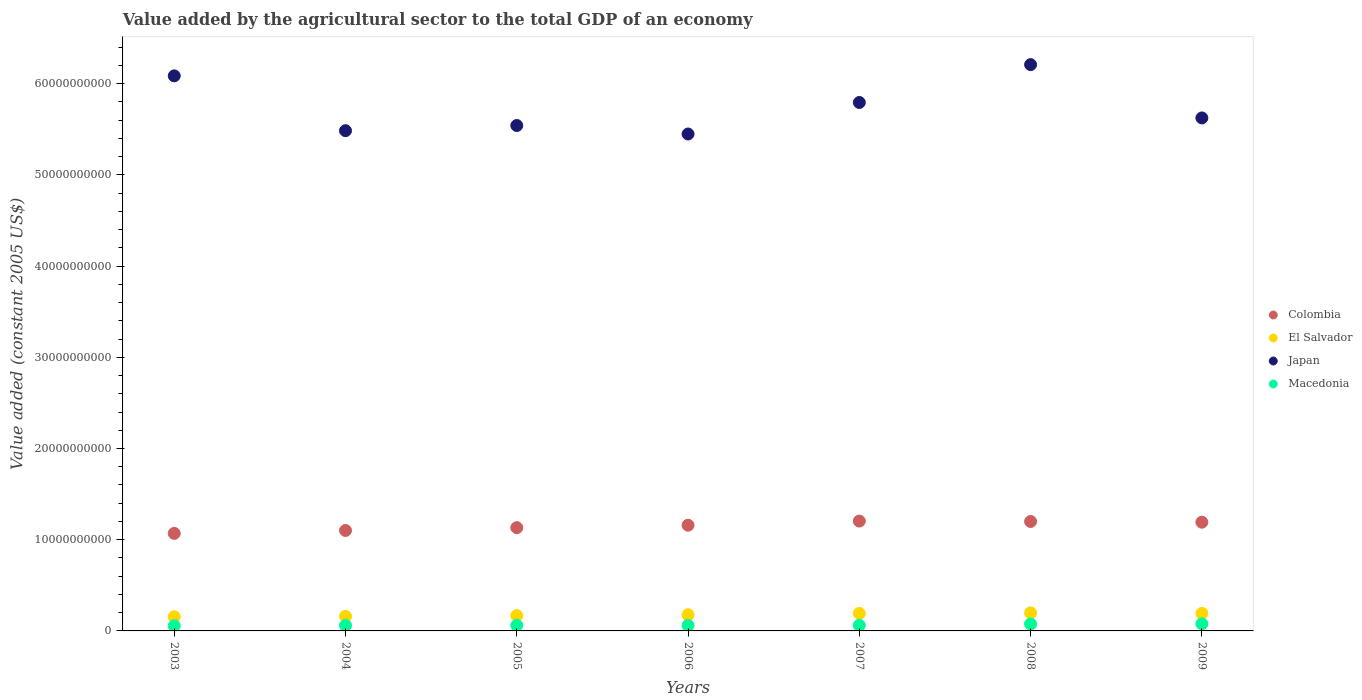Is the number of dotlines equal to the number of legend labels?
Your response must be concise. Yes. What is the value added by the agricultural sector in Colombia in 2009?
Keep it short and to the point. 1.19e+1. Across all years, what is the maximum value added by the agricultural sector in Japan?
Offer a terse response. 6.21e+1. Across all years, what is the minimum value added by the agricultural sector in El Salvador?
Your answer should be very brief. 1.55e+09. In which year was the value added by the agricultural sector in Japan minimum?
Your answer should be very brief. 2006. What is the total value added by the agricultural sector in Macedonia in the graph?
Give a very brief answer. 4.54e+09. What is the difference between the value added by the agricultural sector in El Salvador in 2007 and that in 2008?
Provide a succinct answer. -5.84e+07. What is the difference between the value added by the agricultural sector in El Salvador in 2005 and the value added by the agricultural sector in Japan in 2008?
Keep it short and to the point. -6.04e+1. What is the average value added by the agricultural sector in Japan per year?
Your response must be concise. 5.74e+1. In the year 2005, what is the difference between the value added by the agricultural sector in El Salvador and value added by the agricultural sector in Colombia?
Your answer should be very brief. -9.65e+09. What is the ratio of the value added by the agricultural sector in Colombia in 2004 to that in 2005?
Your answer should be compact. 0.97. Is the difference between the value added by the agricultural sector in El Salvador in 2004 and 2005 greater than the difference between the value added by the agricultural sector in Colombia in 2004 and 2005?
Give a very brief answer. Yes. What is the difference between the highest and the second highest value added by the agricultural sector in Colombia?
Keep it short and to the point. 4.52e+07. What is the difference between the highest and the lowest value added by the agricultural sector in El Salvador?
Offer a very short reply. 4.28e+08. In how many years, is the value added by the agricultural sector in Macedonia greater than the average value added by the agricultural sector in Macedonia taken over all years?
Give a very brief answer. 2. Is the sum of the value added by the agricultural sector in Colombia in 2003 and 2006 greater than the maximum value added by the agricultural sector in Japan across all years?
Offer a very short reply. No. Is it the case that in every year, the sum of the value added by the agricultural sector in Japan and value added by the agricultural sector in El Salvador  is greater than the sum of value added by the agricultural sector in Macedonia and value added by the agricultural sector in Colombia?
Offer a very short reply. Yes. Does the value added by the agricultural sector in Macedonia monotonically increase over the years?
Make the answer very short. No. How many years are there in the graph?
Your answer should be compact. 7. What is the difference between two consecutive major ticks on the Y-axis?
Your answer should be very brief. 1.00e+1. Does the graph contain grids?
Keep it short and to the point. No. How many legend labels are there?
Offer a terse response. 4. What is the title of the graph?
Your answer should be very brief. Value added by the agricultural sector to the total GDP of an economy. What is the label or title of the X-axis?
Make the answer very short. Years. What is the label or title of the Y-axis?
Offer a terse response. Value added (constant 2005 US$). What is the Value added (constant 2005 US$) of Colombia in 2003?
Your response must be concise. 1.07e+1. What is the Value added (constant 2005 US$) in El Salvador in 2003?
Ensure brevity in your answer.  1.55e+09. What is the Value added (constant 2005 US$) of Japan in 2003?
Your response must be concise. 6.09e+1. What is the Value added (constant 2005 US$) in Macedonia in 2003?
Your answer should be very brief. 5.65e+08. What is the Value added (constant 2005 US$) of Colombia in 2004?
Ensure brevity in your answer.  1.10e+1. What is the Value added (constant 2005 US$) of El Salvador in 2004?
Offer a very short reply. 1.60e+09. What is the Value added (constant 2005 US$) of Japan in 2004?
Give a very brief answer. 5.48e+1. What is the Value added (constant 2005 US$) in Macedonia in 2004?
Offer a very short reply. 6.04e+08. What is the Value added (constant 2005 US$) of Colombia in 2005?
Provide a succinct answer. 1.13e+1. What is the Value added (constant 2005 US$) of El Salvador in 2005?
Make the answer very short. 1.68e+09. What is the Value added (constant 2005 US$) of Japan in 2005?
Make the answer very short. 5.54e+1. What is the Value added (constant 2005 US$) in Macedonia in 2005?
Your response must be concise. 6.09e+08. What is the Value added (constant 2005 US$) in Colombia in 2006?
Your response must be concise. 1.16e+1. What is the Value added (constant 2005 US$) of El Salvador in 2006?
Provide a succinct answer. 1.77e+09. What is the Value added (constant 2005 US$) in Japan in 2006?
Your response must be concise. 5.45e+1. What is the Value added (constant 2005 US$) of Macedonia in 2006?
Keep it short and to the point. 6.06e+08. What is the Value added (constant 2005 US$) of Colombia in 2007?
Offer a terse response. 1.20e+1. What is the Value added (constant 2005 US$) of El Salvador in 2007?
Your answer should be compact. 1.92e+09. What is the Value added (constant 2005 US$) in Japan in 2007?
Your response must be concise. 5.79e+1. What is the Value added (constant 2005 US$) of Macedonia in 2007?
Make the answer very short. 6.19e+08. What is the Value added (constant 2005 US$) in Colombia in 2008?
Ensure brevity in your answer.  1.20e+1. What is the Value added (constant 2005 US$) of El Salvador in 2008?
Provide a short and direct response. 1.98e+09. What is the Value added (constant 2005 US$) of Japan in 2008?
Your response must be concise. 6.21e+1. What is the Value added (constant 2005 US$) of Macedonia in 2008?
Offer a terse response. 7.55e+08. What is the Value added (constant 2005 US$) in Colombia in 2009?
Offer a very short reply. 1.19e+1. What is the Value added (constant 2005 US$) of El Salvador in 2009?
Give a very brief answer. 1.92e+09. What is the Value added (constant 2005 US$) in Japan in 2009?
Your response must be concise. 5.62e+1. What is the Value added (constant 2005 US$) in Macedonia in 2009?
Keep it short and to the point. 7.81e+08. Across all years, what is the maximum Value added (constant 2005 US$) in Colombia?
Keep it short and to the point. 1.20e+1. Across all years, what is the maximum Value added (constant 2005 US$) of El Salvador?
Ensure brevity in your answer.  1.98e+09. Across all years, what is the maximum Value added (constant 2005 US$) of Japan?
Give a very brief answer. 6.21e+1. Across all years, what is the maximum Value added (constant 2005 US$) of Macedonia?
Make the answer very short. 7.81e+08. Across all years, what is the minimum Value added (constant 2005 US$) of Colombia?
Provide a short and direct response. 1.07e+1. Across all years, what is the minimum Value added (constant 2005 US$) of El Salvador?
Give a very brief answer. 1.55e+09. Across all years, what is the minimum Value added (constant 2005 US$) in Japan?
Provide a short and direct response. 5.45e+1. Across all years, what is the minimum Value added (constant 2005 US$) in Macedonia?
Provide a succinct answer. 5.65e+08. What is the total Value added (constant 2005 US$) of Colombia in the graph?
Your response must be concise. 8.06e+1. What is the total Value added (constant 2005 US$) in El Salvador in the graph?
Your answer should be very brief. 1.24e+1. What is the total Value added (constant 2005 US$) in Japan in the graph?
Provide a short and direct response. 4.02e+11. What is the total Value added (constant 2005 US$) of Macedonia in the graph?
Offer a very short reply. 4.54e+09. What is the difference between the Value added (constant 2005 US$) in Colombia in 2003 and that in 2004?
Offer a terse response. -3.18e+08. What is the difference between the Value added (constant 2005 US$) in El Salvador in 2003 and that in 2004?
Offer a very short reply. -4.36e+07. What is the difference between the Value added (constant 2005 US$) in Japan in 2003 and that in 2004?
Your answer should be compact. 6.01e+09. What is the difference between the Value added (constant 2005 US$) in Macedonia in 2003 and that in 2004?
Offer a very short reply. -3.82e+07. What is the difference between the Value added (constant 2005 US$) of Colombia in 2003 and that in 2005?
Your response must be concise. -6.28e+08. What is the difference between the Value added (constant 2005 US$) of El Salvador in 2003 and that in 2005?
Ensure brevity in your answer.  -1.25e+08. What is the difference between the Value added (constant 2005 US$) in Japan in 2003 and that in 2005?
Ensure brevity in your answer.  5.44e+09. What is the difference between the Value added (constant 2005 US$) in Macedonia in 2003 and that in 2005?
Offer a very short reply. -4.40e+07. What is the difference between the Value added (constant 2005 US$) of Colombia in 2003 and that in 2006?
Your answer should be very brief. -8.97e+08. What is the difference between the Value added (constant 2005 US$) in El Salvador in 2003 and that in 2006?
Your response must be concise. -2.20e+08. What is the difference between the Value added (constant 2005 US$) in Japan in 2003 and that in 2006?
Offer a very short reply. 6.38e+09. What is the difference between the Value added (constant 2005 US$) of Macedonia in 2003 and that in 2006?
Your response must be concise. -4.07e+07. What is the difference between the Value added (constant 2005 US$) in Colombia in 2003 and that in 2007?
Offer a terse response. -1.35e+09. What is the difference between the Value added (constant 2005 US$) in El Salvador in 2003 and that in 2007?
Provide a short and direct response. -3.70e+08. What is the difference between the Value added (constant 2005 US$) in Japan in 2003 and that in 2007?
Offer a terse response. 2.92e+09. What is the difference between the Value added (constant 2005 US$) of Macedonia in 2003 and that in 2007?
Your answer should be compact. -5.37e+07. What is the difference between the Value added (constant 2005 US$) of Colombia in 2003 and that in 2008?
Provide a short and direct response. -1.30e+09. What is the difference between the Value added (constant 2005 US$) of El Salvador in 2003 and that in 2008?
Your answer should be compact. -4.28e+08. What is the difference between the Value added (constant 2005 US$) of Japan in 2003 and that in 2008?
Offer a very short reply. -1.23e+09. What is the difference between the Value added (constant 2005 US$) of Macedonia in 2003 and that in 2008?
Provide a succinct answer. -1.90e+08. What is the difference between the Value added (constant 2005 US$) of Colombia in 2003 and that in 2009?
Give a very brief answer. -1.23e+09. What is the difference between the Value added (constant 2005 US$) in El Salvador in 2003 and that in 2009?
Keep it short and to the point. -3.71e+08. What is the difference between the Value added (constant 2005 US$) in Japan in 2003 and that in 2009?
Your response must be concise. 4.61e+09. What is the difference between the Value added (constant 2005 US$) in Macedonia in 2003 and that in 2009?
Keep it short and to the point. -2.16e+08. What is the difference between the Value added (constant 2005 US$) of Colombia in 2004 and that in 2005?
Your answer should be very brief. -3.10e+08. What is the difference between the Value added (constant 2005 US$) of El Salvador in 2004 and that in 2005?
Provide a short and direct response. -8.10e+07. What is the difference between the Value added (constant 2005 US$) in Japan in 2004 and that in 2005?
Make the answer very short. -5.68e+08. What is the difference between the Value added (constant 2005 US$) in Macedonia in 2004 and that in 2005?
Provide a succinct answer. -5.80e+06. What is the difference between the Value added (constant 2005 US$) of Colombia in 2004 and that in 2006?
Offer a very short reply. -5.78e+08. What is the difference between the Value added (constant 2005 US$) in El Salvador in 2004 and that in 2006?
Give a very brief answer. -1.76e+08. What is the difference between the Value added (constant 2005 US$) in Japan in 2004 and that in 2006?
Make the answer very short. 3.65e+08. What is the difference between the Value added (constant 2005 US$) of Macedonia in 2004 and that in 2006?
Provide a short and direct response. -2.50e+06. What is the difference between the Value added (constant 2005 US$) in Colombia in 2004 and that in 2007?
Give a very brief answer. -1.03e+09. What is the difference between the Value added (constant 2005 US$) of El Salvador in 2004 and that in 2007?
Ensure brevity in your answer.  -3.26e+08. What is the difference between the Value added (constant 2005 US$) of Japan in 2004 and that in 2007?
Offer a very short reply. -3.09e+09. What is the difference between the Value added (constant 2005 US$) in Macedonia in 2004 and that in 2007?
Your response must be concise. -1.56e+07. What is the difference between the Value added (constant 2005 US$) in Colombia in 2004 and that in 2008?
Your response must be concise. -9.86e+08. What is the difference between the Value added (constant 2005 US$) of El Salvador in 2004 and that in 2008?
Offer a very short reply. -3.84e+08. What is the difference between the Value added (constant 2005 US$) of Japan in 2004 and that in 2008?
Keep it short and to the point. -7.24e+09. What is the difference between the Value added (constant 2005 US$) in Macedonia in 2004 and that in 2008?
Make the answer very short. -1.52e+08. What is the difference between the Value added (constant 2005 US$) of Colombia in 2004 and that in 2009?
Give a very brief answer. -9.08e+08. What is the difference between the Value added (constant 2005 US$) in El Salvador in 2004 and that in 2009?
Ensure brevity in your answer.  -3.27e+08. What is the difference between the Value added (constant 2005 US$) in Japan in 2004 and that in 2009?
Offer a very short reply. -1.40e+09. What is the difference between the Value added (constant 2005 US$) of Macedonia in 2004 and that in 2009?
Keep it short and to the point. -1.77e+08. What is the difference between the Value added (constant 2005 US$) of Colombia in 2005 and that in 2006?
Keep it short and to the point. -2.68e+08. What is the difference between the Value added (constant 2005 US$) of El Salvador in 2005 and that in 2006?
Make the answer very short. -9.51e+07. What is the difference between the Value added (constant 2005 US$) in Japan in 2005 and that in 2006?
Your response must be concise. 9.33e+08. What is the difference between the Value added (constant 2005 US$) of Macedonia in 2005 and that in 2006?
Your response must be concise. 3.31e+06. What is the difference between the Value added (constant 2005 US$) in Colombia in 2005 and that in 2007?
Your answer should be compact. -7.22e+08. What is the difference between the Value added (constant 2005 US$) in El Salvador in 2005 and that in 2007?
Make the answer very short. -2.45e+08. What is the difference between the Value added (constant 2005 US$) of Japan in 2005 and that in 2007?
Keep it short and to the point. -2.52e+09. What is the difference between the Value added (constant 2005 US$) of Macedonia in 2005 and that in 2007?
Your response must be concise. -9.75e+06. What is the difference between the Value added (constant 2005 US$) in Colombia in 2005 and that in 2008?
Give a very brief answer. -6.76e+08. What is the difference between the Value added (constant 2005 US$) in El Salvador in 2005 and that in 2008?
Your response must be concise. -3.03e+08. What is the difference between the Value added (constant 2005 US$) of Japan in 2005 and that in 2008?
Offer a very short reply. -6.67e+09. What is the difference between the Value added (constant 2005 US$) of Macedonia in 2005 and that in 2008?
Offer a terse response. -1.46e+08. What is the difference between the Value added (constant 2005 US$) in Colombia in 2005 and that in 2009?
Your answer should be compact. -5.98e+08. What is the difference between the Value added (constant 2005 US$) in El Salvador in 2005 and that in 2009?
Ensure brevity in your answer.  -2.46e+08. What is the difference between the Value added (constant 2005 US$) in Japan in 2005 and that in 2009?
Your answer should be very brief. -8.29e+08. What is the difference between the Value added (constant 2005 US$) of Macedonia in 2005 and that in 2009?
Ensure brevity in your answer.  -1.72e+08. What is the difference between the Value added (constant 2005 US$) of Colombia in 2006 and that in 2007?
Provide a succinct answer. -4.53e+08. What is the difference between the Value added (constant 2005 US$) of El Salvador in 2006 and that in 2007?
Your answer should be compact. -1.50e+08. What is the difference between the Value added (constant 2005 US$) in Japan in 2006 and that in 2007?
Provide a succinct answer. -3.46e+09. What is the difference between the Value added (constant 2005 US$) of Macedonia in 2006 and that in 2007?
Offer a very short reply. -1.31e+07. What is the difference between the Value added (constant 2005 US$) in Colombia in 2006 and that in 2008?
Keep it short and to the point. -4.08e+08. What is the difference between the Value added (constant 2005 US$) in El Salvador in 2006 and that in 2008?
Offer a very short reply. -2.08e+08. What is the difference between the Value added (constant 2005 US$) of Japan in 2006 and that in 2008?
Your response must be concise. -7.61e+09. What is the difference between the Value added (constant 2005 US$) of Macedonia in 2006 and that in 2008?
Your response must be concise. -1.49e+08. What is the difference between the Value added (constant 2005 US$) of Colombia in 2006 and that in 2009?
Your answer should be compact. -3.30e+08. What is the difference between the Value added (constant 2005 US$) of El Salvador in 2006 and that in 2009?
Provide a succinct answer. -1.51e+08. What is the difference between the Value added (constant 2005 US$) in Japan in 2006 and that in 2009?
Provide a short and direct response. -1.76e+09. What is the difference between the Value added (constant 2005 US$) of Macedonia in 2006 and that in 2009?
Ensure brevity in your answer.  -1.75e+08. What is the difference between the Value added (constant 2005 US$) in Colombia in 2007 and that in 2008?
Provide a succinct answer. 4.52e+07. What is the difference between the Value added (constant 2005 US$) of El Salvador in 2007 and that in 2008?
Provide a succinct answer. -5.84e+07. What is the difference between the Value added (constant 2005 US$) of Japan in 2007 and that in 2008?
Your response must be concise. -4.15e+09. What is the difference between the Value added (constant 2005 US$) in Macedonia in 2007 and that in 2008?
Your answer should be compact. -1.36e+08. What is the difference between the Value added (constant 2005 US$) in Colombia in 2007 and that in 2009?
Offer a terse response. 1.24e+08. What is the difference between the Value added (constant 2005 US$) of El Salvador in 2007 and that in 2009?
Keep it short and to the point. -1.02e+06. What is the difference between the Value added (constant 2005 US$) of Japan in 2007 and that in 2009?
Provide a succinct answer. 1.69e+09. What is the difference between the Value added (constant 2005 US$) of Macedonia in 2007 and that in 2009?
Ensure brevity in your answer.  -1.62e+08. What is the difference between the Value added (constant 2005 US$) of Colombia in 2008 and that in 2009?
Make the answer very short. 7.84e+07. What is the difference between the Value added (constant 2005 US$) of El Salvador in 2008 and that in 2009?
Ensure brevity in your answer.  5.73e+07. What is the difference between the Value added (constant 2005 US$) of Japan in 2008 and that in 2009?
Offer a terse response. 5.84e+09. What is the difference between the Value added (constant 2005 US$) in Macedonia in 2008 and that in 2009?
Offer a terse response. -2.57e+07. What is the difference between the Value added (constant 2005 US$) in Colombia in 2003 and the Value added (constant 2005 US$) in El Salvador in 2004?
Keep it short and to the point. 9.10e+09. What is the difference between the Value added (constant 2005 US$) in Colombia in 2003 and the Value added (constant 2005 US$) in Japan in 2004?
Keep it short and to the point. -4.42e+1. What is the difference between the Value added (constant 2005 US$) in Colombia in 2003 and the Value added (constant 2005 US$) in Macedonia in 2004?
Your answer should be compact. 1.01e+1. What is the difference between the Value added (constant 2005 US$) of El Salvador in 2003 and the Value added (constant 2005 US$) of Japan in 2004?
Provide a succinct answer. -5.33e+1. What is the difference between the Value added (constant 2005 US$) of El Salvador in 2003 and the Value added (constant 2005 US$) of Macedonia in 2004?
Your answer should be compact. 9.49e+08. What is the difference between the Value added (constant 2005 US$) of Japan in 2003 and the Value added (constant 2005 US$) of Macedonia in 2004?
Give a very brief answer. 6.03e+1. What is the difference between the Value added (constant 2005 US$) of Colombia in 2003 and the Value added (constant 2005 US$) of El Salvador in 2005?
Give a very brief answer. 9.02e+09. What is the difference between the Value added (constant 2005 US$) of Colombia in 2003 and the Value added (constant 2005 US$) of Japan in 2005?
Your response must be concise. -4.47e+1. What is the difference between the Value added (constant 2005 US$) in Colombia in 2003 and the Value added (constant 2005 US$) in Macedonia in 2005?
Make the answer very short. 1.01e+1. What is the difference between the Value added (constant 2005 US$) of El Salvador in 2003 and the Value added (constant 2005 US$) of Japan in 2005?
Ensure brevity in your answer.  -5.39e+1. What is the difference between the Value added (constant 2005 US$) in El Salvador in 2003 and the Value added (constant 2005 US$) in Macedonia in 2005?
Offer a terse response. 9.43e+08. What is the difference between the Value added (constant 2005 US$) of Japan in 2003 and the Value added (constant 2005 US$) of Macedonia in 2005?
Make the answer very short. 6.02e+1. What is the difference between the Value added (constant 2005 US$) of Colombia in 2003 and the Value added (constant 2005 US$) of El Salvador in 2006?
Provide a succinct answer. 8.92e+09. What is the difference between the Value added (constant 2005 US$) in Colombia in 2003 and the Value added (constant 2005 US$) in Japan in 2006?
Give a very brief answer. -4.38e+1. What is the difference between the Value added (constant 2005 US$) in Colombia in 2003 and the Value added (constant 2005 US$) in Macedonia in 2006?
Your response must be concise. 1.01e+1. What is the difference between the Value added (constant 2005 US$) in El Salvador in 2003 and the Value added (constant 2005 US$) in Japan in 2006?
Make the answer very short. -5.29e+1. What is the difference between the Value added (constant 2005 US$) in El Salvador in 2003 and the Value added (constant 2005 US$) in Macedonia in 2006?
Offer a terse response. 9.46e+08. What is the difference between the Value added (constant 2005 US$) of Japan in 2003 and the Value added (constant 2005 US$) of Macedonia in 2006?
Your response must be concise. 6.03e+1. What is the difference between the Value added (constant 2005 US$) in Colombia in 2003 and the Value added (constant 2005 US$) in El Salvador in 2007?
Give a very brief answer. 8.77e+09. What is the difference between the Value added (constant 2005 US$) of Colombia in 2003 and the Value added (constant 2005 US$) of Japan in 2007?
Provide a succinct answer. -4.72e+1. What is the difference between the Value added (constant 2005 US$) in Colombia in 2003 and the Value added (constant 2005 US$) in Macedonia in 2007?
Your answer should be compact. 1.01e+1. What is the difference between the Value added (constant 2005 US$) in El Salvador in 2003 and the Value added (constant 2005 US$) in Japan in 2007?
Ensure brevity in your answer.  -5.64e+1. What is the difference between the Value added (constant 2005 US$) in El Salvador in 2003 and the Value added (constant 2005 US$) in Macedonia in 2007?
Make the answer very short. 9.33e+08. What is the difference between the Value added (constant 2005 US$) of Japan in 2003 and the Value added (constant 2005 US$) of Macedonia in 2007?
Give a very brief answer. 6.02e+1. What is the difference between the Value added (constant 2005 US$) in Colombia in 2003 and the Value added (constant 2005 US$) in El Salvador in 2008?
Offer a very short reply. 8.71e+09. What is the difference between the Value added (constant 2005 US$) in Colombia in 2003 and the Value added (constant 2005 US$) in Japan in 2008?
Keep it short and to the point. -5.14e+1. What is the difference between the Value added (constant 2005 US$) of Colombia in 2003 and the Value added (constant 2005 US$) of Macedonia in 2008?
Your answer should be compact. 9.94e+09. What is the difference between the Value added (constant 2005 US$) of El Salvador in 2003 and the Value added (constant 2005 US$) of Japan in 2008?
Your answer should be compact. -6.05e+1. What is the difference between the Value added (constant 2005 US$) in El Salvador in 2003 and the Value added (constant 2005 US$) in Macedonia in 2008?
Ensure brevity in your answer.  7.97e+08. What is the difference between the Value added (constant 2005 US$) in Japan in 2003 and the Value added (constant 2005 US$) in Macedonia in 2008?
Your answer should be very brief. 6.01e+1. What is the difference between the Value added (constant 2005 US$) in Colombia in 2003 and the Value added (constant 2005 US$) in El Salvador in 2009?
Give a very brief answer. 8.77e+09. What is the difference between the Value added (constant 2005 US$) in Colombia in 2003 and the Value added (constant 2005 US$) in Japan in 2009?
Ensure brevity in your answer.  -4.55e+1. What is the difference between the Value added (constant 2005 US$) in Colombia in 2003 and the Value added (constant 2005 US$) in Macedonia in 2009?
Ensure brevity in your answer.  9.91e+09. What is the difference between the Value added (constant 2005 US$) in El Salvador in 2003 and the Value added (constant 2005 US$) in Japan in 2009?
Provide a succinct answer. -5.47e+1. What is the difference between the Value added (constant 2005 US$) of El Salvador in 2003 and the Value added (constant 2005 US$) of Macedonia in 2009?
Keep it short and to the point. 7.72e+08. What is the difference between the Value added (constant 2005 US$) in Japan in 2003 and the Value added (constant 2005 US$) in Macedonia in 2009?
Give a very brief answer. 6.01e+1. What is the difference between the Value added (constant 2005 US$) in Colombia in 2004 and the Value added (constant 2005 US$) in El Salvador in 2005?
Your response must be concise. 9.34e+09. What is the difference between the Value added (constant 2005 US$) of Colombia in 2004 and the Value added (constant 2005 US$) of Japan in 2005?
Your response must be concise. -4.44e+1. What is the difference between the Value added (constant 2005 US$) in Colombia in 2004 and the Value added (constant 2005 US$) in Macedonia in 2005?
Provide a succinct answer. 1.04e+1. What is the difference between the Value added (constant 2005 US$) in El Salvador in 2004 and the Value added (constant 2005 US$) in Japan in 2005?
Provide a short and direct response. -5.38e+1. What is the difference between the Value added (constant 2005 US$) in El Salvador in 2004 and the Value added (constant 2005 US$) in Macedonia in 2005?
Your response must be concise. 9.87e+08. What is the difference between the Value added (constant 2005 US$) in Japan in 2004 and the Value added (constant 2005 US$) in Macedonia in 2005?
Give a very brief answer. 5.42e+1. What is the difference between the Value added (constant 2005 US$) in Colombia in 2004 and the Value added (constant 2005 US$) in El Salvador in 2006?
Ensure brevity in your answer.  9.24e+09. What is the difference between the Value added (constant 2005 US$) in Colombia in 2004 and the Value added (constant 2005 US$) in Japan in 2006?
Your answer should be very brief. -4.35e+1. What is the difference between the Value added (constant 2005 US$) in Colombia in 2004 and the Value added (constant 2005 US$) in Macedonia in 2006?
Keep it short and to the point. 1.04e+1. What is the difference between the Value added (constant 2005 US$) of El Salvador in 2004 and the Value added (constant 2005 US$) of Japan in 2006?
Your answer should be very brief. -5.29e+1. What is the difference between the Value added (constant 2005 US$) in El Salvador in 2004 and the Value added (constant 2005 US$) in Macedonia in 2006?
Make the answer very short. 9.90e+08. What is the difference between the Value added (constant 2005 US$) in Japan in 2004 and the Value added (constant 2005 US$) in Macedonia in 2006?
Offer a very short reply. 5.42e+1. What is the difference between the Value added (constant 2005 US$) in Colombia in 2004 and the Value added (constant 2005 US$) in El Salvador in 2007?
Your answer should be compact. 9.09e+09. What is the difference between the Value added (constant 2005 US$) of Colombia in 2004 and the Value added (constant 2005 US$) of Japan in 2007?
Give a very brief answer. -4.69e+1. What is the difference between the Value added (constant 2005 US$) in Colombia in 2004 and the Value added (constant 2005 US$) in Macedonia in 2007?
Your response must be concise. 1.04e+1. What is the difference between the Value added (constant 2005 US$) of El Salvador in 2004 and the Value added (constant 2005 US$) of Japan in 2007?
Offer a terse response. -5.63e+1. What is the difference between the Value added (constant 2005 US$) in El Salvador in 2004 and the Value added (constant 2005 US$) in Macedonia in 2007?
Provide a short and direct response. 9.77e+08. What is the difference between the Value added (constant 2005 US$) in Japan in 2004 and the Value added (constant 2005 US$) in Macedonia in 2007?
Your answer should be very brief. 5.42e+1. What is the difference between the Value added (constant 2005 US$) in Colombia in 2004 and the Value added (constant 2005 US$) in El Salvador in 2008?
Make the answer very short. 9.03e+09. What is the difference between the Value added (constant 2005 US$) in Colombia in 2004 and the Value added (constant 2005 US$) in Japan in 2008?
Offer a very short reply. -5.11e+1. What is the difference between the Value added (constant 2005 US$) of Colombia in 2004 and the Value added (constant 2005 US$) of Macedonia in 2008?
Your answer should be compact. 1.03e+1. What is the difference between the Value added (constant 2005 US$) in El Salvador in 2004 and the Value added (constant 2005 US$) in Japan in 2008?
Offer a terse response. -6.05e+1. What is the difference between the Value added (constant 2005 US$) of El Salvador in 2004 and the Value added (constant 2005 US$) of Macedonia in 2008?
Offer a very short reply. 8.41e+08. What is the difference between the Value added (constant 2005 US$) of Japan in 2004 and the Value added (constant 2005 US$) of Macedonia in 2008?
Give a very brief answer. 5.41e+1. What is the difference between the Value added (constant 2005 US$) in Colombia in 2004 and the Value added (constant 2005 US$) in El Salvador in 2009?
Your response must be concise. 9.09e+09. What is the difference between the Value added (constant 2005 US$) of Colombia in 2004 and the Value added (constant 2005 US$) of Japan in 2009?
Your response must be concise. -4.52e+1. What is the difference between the Value added (constant 2005 US$) in Colombia in 2004 and the Value added (constant 2005 US$) in Macedonia in 2009?
Provide a succinct answer. 1.02e+1. What is the difference between the Value added (constant 2005 US$) in El Salvador in 2004 and the Value added (constant 2005 US$) in Japan in 2009?
Offer a very short reply. -5.46e+1. What is the difference between the Value added (constant 2005 US$) of El Salvador in 2004 and the Value added (constant 2005 US$) of Macedonia in 2009?
Offer a terse response. 8.15e+08. What is the difference between the Value added (constant 2005 US$) of Japan in 2004 and the Value added (constant 2005 US$) of Macedonia in 2009?
Keep it short and to the point. 5.41e+1. What is the difference between the Value added (constant 2005 US$) of Colombia in 2005 and the Value added (constant 2005 US$) of El Salvador in 2006?
Your answer should be compact. 9.55e+09. What is the difference between the Value added (constant 2005 US$) of Colombia in 2005 and the Value added (constant 2005 US$) of Japan in 2006?
Your response must be concise. -4.32e+1. What is the difference between the Value added (constant 2005 US$) of Colombia in 2005 and the Value added (constant 2005 US$) of Macedonia in 2006?
Offer a very short reply. 1.07e+1. What is the difference between the Value added (constant 2005 US$) of El Salvador in 2005 and the Value added (constant 2005 US$) of Japan in 2006?
Give a very brief answer. -5.28e+1. What is the difference between the Value added (constant 2005 US$) in El Salvador in 2005 and the Value added (constant 2005 US$) in Macedonia in 2006?
Your response must be concise. 1.07e+09. What is the difference between the Value added (constant 2005 US$) of Japan in 2005 and the Value added (constant 2005 US$) of Macedonia in 2006?
Your answer should be very brief. 5.48e+1. What is the difference between the Value added (constant 2005 US$) in Colombia in 2005 and the Value added (constant 2005 US$) in El Salvador in 2007?
Provide a succinct answer. 9.40e+09. What is the difference between the Value added (constant 2005 US$) in Colombia in 2005 and the Value added (constant 2005 US$) in Japan in 2007?
Offer a very short reply. -4.66e+1. What is the difference between the Value added (constant 2005 US$) in Colombia in 2005 and the Value added (constant 2005 US$) in Macedonia in 2007?
Your answer should be compact. 1.07e+1. What is the difference between the Value added (constant 2005 US$) in El Salvador in 2005 and the Value added (constant 2005 US$) in Japan in 2007?
Your answer should be very brief. -5.63e+1. What is the difference between the Value added (constant 2005 US$) in El Salvador in 2005 and the Value added (constant 2005 US$) in Macedonia in 2007?
Keep it short and to the point. 1.06e+09. What is the difference between the Value added (constant 2005 US$) in Japan in 2005 and the Value added (constant 2005 US$) in Macedonia in 2007?
Make the answer very short. 5.48e+1. What is the difference between the Value added (constant 2005 US$) in Colombia in 2005 and the Value added (constant 2005 US$) in El Salvador in 2008?
Your response must be concise. 9.34e+09. What is the difference between the Value added (constant 2005 US$) in Colombia in 2005 and the Value added (constant 2005 US$) in Japan in 2008?
Keep it short and to the point. -5.08e+1. What is the difference between the Value added (constant 2005 US$) in Colombia in 2005 and the Value added (constant 2005 US$) in Macedonia in 2008?
Provide a succinct answer. 1.06e+1. What is the difference between the Value added (constant 2005 US$) in El Salvador in 2005 and the Value added (constant 2005 US$) in Japan in 2008?
Ensure brevity in your answer.  -6.04e+1. What is the difference between the Value added (constant 2005 US$) of El Salvador in 2005 and the Value added (constant 2005 US$) of Macedonia in 2008?
Ensure brevity in your answer.  9.22e+08. What is the difference between the Value added (constant 2005 US$) of Japan in 2005 and the Value added (constant 2005 US$) of Macedonia in 2008?
Make the answer very short. 5.47e+1. What is the difference between the Value added (constant 2005 US$) of Colombia in 2005 and the Value added (constant 2005 US$) of El Salvador in 2009?
Ensure brevity in your answer.  9.40e+09. What is the difference between the Value added (constant 2005 US$) of Colombia in 2005 and the Value added (constant 2005 US$) of Japan in 2009?
Make the answer very short. -4.49e+1. What is the difference between the Value added (constant 2005 US$) in Colombia in 2005 and the Value added (constant 2005 US$) in Macedonia in 2009?
Give a very brief answer. 1.05e+1. What is the difference between the Value added (constant 2005 US$) in El Salvador in 2005 and the Value added (constant 2005 US$) in Japan in 2009?
Offer a very short reply. -5.46e+1. What is the difference between the Value added (constant 2005 US$) in El Salvador in 2005 and the Value added (constant 2005 US$) in Macedonia in 2009?
Give a very brief answer. 8.96e+08. What is the difference between the Value added (constant 2005 US$) in Japan in 2005 and the Value added (constant 2005 US$) in Macedonia in 2009?
Make the answer very short. 5.46e+1. What is the difference between the Value added (constant 2005 US$) in Colombia in 2006 and the Value added (constant 2005 US$) in El Salvador in 2007?
Provide a short and direct response. 9.67e+09. What is the difference between the Value added (constant 2005 US$) in Colombia in 2006 and the Value added (constant 2005 US$) in Japan in 2007?
Your answer should be very brief. -4.63e+1. What is the difference between the Value added (constant 2005 US$) of Colombia in 2006 and the Value added (constant 2005 US$) of Macedonia in 2007?
Make the answer very short. 1.10e+1. What is the difference between the Value added (constant 2005 US$) of El Salvador in 2006 and the Value added (constant 2005 US$) of Japan in 2007?
Offer a terse response. -5.62e+1. What is the difference between the Value added (constant 2005 US$) in El Salvador in 2006 and the Value added (constant 2005 US$) in Macedonia in 2007?
Your response must be concise. 1.15e+09. What is the difference between the Value added (constant 2005 US$) of Japan in 2006 and the Value added (constant 2005 US$) of Macedonia in 2007?
Your answer should be compact. 5.39e+1. What is the difference between the Value added (constant 2005 US$) of Colombia in 2006 and the Value added (constant 2005 US$) of El Salvador in 2008?
Keep it short and to the point. 9.61e+09. What is the difference between the Value added (constant 2005 US$) of Colombia in 2006 and the Value added (constant 2005 US$) of Japan in 2008?
Make the answer very short. -5.05e+1. What is the difference between the Value added (constant 2005 US$) of Colombia in 2006 and the Value added (constant 2005 US$) of Macedonia in 2008?
Make the answer very short. 1.08e+1. What is the difference between the Value added (constant 2005 US$) of El Salvador in 2006 and the Value added (constant 2005 US$) of Japan in 2008?
Offer a very short reply. -6.03e+1. What is the difference between the Value added (constant 2005 US$) of El Salvador in 2006 and the Value added (constant 2005 US$) of Macedonia in 2008?
Provide a short and direct response. 1.02e+09. What is the difference between the Value added (constant 2005 US$) of Japan in 2006 and the Value added (constant 2005 US$) of Macedonia in 2008?
Provide a short and direct response. 5.37e+1. What is the difference between the Value added (constant 2005 US$) of Colombia in 2006 and the Value added (constant 2005 US$) of El Salvador in 2009?
Give a very brief answer. 9.67e+09. What is the difference between the Value added (constant 2005 US$) in Colombia in 2006 and the Value added (constant 2005 US$) in Japan in 2009?
Keep it short and to the point. -4.47e+1. What is the difference between the Value added (constant 2005 US$) of Colombia in 2006 and the Value added (constant 2005 US$) of Macedonia in 2009?
Offer a terse response. 1.08e+1. What is the difference between the Value added (constant 2005 US$) of El Salvador in 2006 and the Value added (constant 2005 US$) of Japan in 2009?
Provide a short and direct response. -5.45e+1. What is the difference between the Value added (constant 2005 US$) in El Salvador in 2006 and the Value added (constant 2005 US$) in Macedonia in 2009?
Give a very brief answer. 9.91e+08. What is the difference between the Value added (constant 2005 US$) in Japan in 2006 and the Value added (constant 2005 US$) in Macedonia in 2009?
Your response must be concise. 5.37e+1. What is the difference between the Value added (constant 2005 US$) in Colombia in 2007 and the Value added (constant 2005 US$) in El Salvador in 2008?
Provide a short and direct response. 1.01e+1. What is the difference between the Value added (constant 2005 US$) in Colombia in 2007 and the Value added (constant 2005 US$) in Japan in 2008?
Make the answer very short. -5.00e+1. What is the difference between the Value added (constant 2005 US$) in Colombia in 2007 and the Value added (constant 2005 US$) in Macedonia in 2008?
Make the answer very short. 1.13e+1. What is the difference between the Value added (constant 2005 US$) in El Salvador in 2007 and the Value added (constant 2005 US$) in Japan in 2008?
Keep it short and to the point. -6.02e+1. What is the difference between the Value added (constant 2005 US$) of El Salvador in 2007 and the Value added (constant 2005 US$) of Macedonia in 2008?
Ensure brevity in your answer.  1.17e+09. What is the difference between the Value added (constant 2005 US$) in Japan in 2007 and the Value added (constant 2005 US$) in Macedonia in 2008?
Make the answer very short. 5.72e+1. What is the difference between the Value added (constant 2005 US$) in Colombia in 2007 and the Value added (constant 2005 US$) in El Salvador in 2009?
Your answer should be very brief. 1.01e+1. What is the difference between the Value added (constant 2005 US$) in Colombia in 2007 and the Value added (constant 2005 US$) in Japan in 2009?
Your response must be concise. -4.42e+1. What is the difference between the Value added (constant 2005 US$) in Colombia in 2007 and the Value added (constant 2005 US$) in Macedonia in 2009?
Provide a succinct answer. 1.13e+1. What is the difference between the Value added (constant 2005 US$) in El Salvador in 2007 and the Value added (constant 2005 US$) in Japan in 2009?
Ensure brevity in your answer.  -5.43e+1. What is the difference between the Value added (constant 2005 US$) of El Salvador in 2007 and the Value added (constant 2005 US$) of Macedonia in 2009?
Offer a terse response. 1.14e+09. What is the difference between the Value added (constant 2005 US$) of Japan in 2007 and the Value added (constant 2005 US$) of Macedonia in 2009?
Offer a very short reply. 5.72e+1. What is the difference between the Value added (constant 2005 US$) in Colombia in 2008 and the Value added (constant 2005 US$) in El Salvador in 2009?
Your answer should be compact. 1.01e+1. What is the difference between the Value added (constant 2005 US$) in Colombia in 2008 and the Value added (constant 2005 US$) in Japan in 2009?
Your answer should be very brief. -4.42e+1. What is the difference between the Value added (constant 2005 US$) of Colombia in 2008 and the Value added (constant 2005 US$) of Macedonia in 2009?
Make the answer very short. 1.12e+1. What is the difference between the Value added (constant 2005 US$) of El Salvador in 2008 and the Value added (constant 2005 US$) of Japan in 2009?
Provide a short and direct response. -5.43e+1. What is the difference between the Value added (constant 2005 US$) in El Salvador in 2008 and the Value added (constant 2005 US$) in Macedonia in 2009?
Provide a short and direct response. 1.20e+09. What is the difference between the Value added (constant 2005 US$) of Japan in 2008 and the Value added (constant 2005 US$) of Macedonia in 2009?
Your answer should be compact. 6.13e+1. What is the average Value added (constant 2005 US$) in Colombia per year?
Ensure brevity in your answer.  1.15e+1. What is the average Value added (constant 2005 US$) in El Salvador per year?
Your answer should be very brief. 1.77e+09. What is the average Value added (constant 2005 US$) of Japan per year?
Offer a terse response. 5.74e+1. What is the average Value added (constant 2005 US$) of Macedonia per year?
Your answer should be very brief. 6.49e+08. In the year 2003, what is the difference between the Value added (constant 2005 US$) in Colombia and Value added (constant 2005 US$) in El Salvador?
Offer a terse response. 9.14e+09. In the year 2003, what is the difference between the Value added (constant 2005 US$) of Colombia and Value added (constant 2005 US$) of Japan?
Keep it short and to the point. -5.02e+1. In the year 2003, what is the difference between the Value added (constant 2005 US$) of Colombia and Value added (constant 2005 US$) of Macedonia?
Make the answer very short. 1.01e+1. In the year 2003, what is the difference between the Value added (constant 2005 US$) in El Salvador and Value added (constant 2005 US$) in Japan?
Keep it short and to the point. -5.93e+1. In the year 2003, what is the difference between the Value added (constant 2005 US$) in El Salvador and Value added (constant 2005 US$) in Macedonia?
Provide a short and direct response. 9.87e+08. In the year 2003, what is the difference between the Value added (constant 2005 US$) in Japan and Value added (constant 2005 US$) in Macedonia?
Your answer should be very brief. 6.03e+1. In the year 2004, what is the difference between the Value added (constant 2005 US$) in Colombia and Value added (constant 2005 US$) in El Salvador?
Your response must be concise. 9.42e+09. In the year 2004, what is the difference between the Value added (constant 2005 US$) in Colombia and Value added (constant 2005 US$) in Japan?
Your answer should be compact. -4.38e+1. In the year 2004, what is the difference between the Value added (constant 2005 US$) of Colombia and Value added (constant 2005 US$) of Macedonia?
Your response must be concise. 1.04e+1. In the year 2004, what is the difference between the Value added (constant 2005 US$) in El Salvador and Value added (constant 2005 US$) in Japan?
Your response must be concise. -5.33e+1. In the year 2004, what is the difference between the Value added (constant 2005 US$) in El Salvador and Value added (constant 2005 US$) in Macedonia?
Your response must be concise. 9.92e+08. In the year 2004, what is the difference between the Value added (constant 2005 US$) in Japan and Value added (constant 2005 US$) in Macedonia?
Keep it short and to the point. 5.42e+1. In the year 2005, what is the difference between the Value added (constant 2005 US$) of Colombia and Value added (constant 2005 US$) of El Salvador?
Offer a terse response. 9.65e+09. In the year 2005, what is the difference between the Value added (constant 2005 US$) in Colombia and Value added (constant 2005 US$) in Japan?
Offer a terse response. -4.41e+1. In the year 2005, what is the difference between the Value added (constant 2005 US$) in Colombia and Value added (constant 2005 US$) in Macedonia?
Offer a terse response. 1.07e+1. In the year 2005, what is the difference between the Value added (constant 2005 US$) in El Salvador and Value added (constant 2005 US$) in Japan?
Give a very brief answer. -5.37e+1. In the year 2005, what is the difference between the Value added (constant 2005 US$) of El Salvador and Value added (constant 2005 US$) of Macedonia?
Offer a very short reply. 1.07e+09. In the year 2005, what is the difference between the Value added (constant 2005 US$) of Japan and Value added (constant 2005 US$) of Macedonia?
Offer a terse response. 5.48e+1. In the year 2006, what is the difference between the Value added (constant 2005 US$) of Colombia and Value added (constant 2005 US$) of El Salvador?
Your answer should be compact. 9.82e+09. In the year 2006, what is the difference between the Value added (constant 2005 US$) of Colombia and Value added (constant 2005 US$) of Japan?
Your response must be concise. -4.29e+1. In the year 2006, what is the difference between the Value added (constant 2005 US$) in Colombia and Value added (constant 2005 US$) in Macedonia?
Provide a short and direct response. 1.10e+1. In the year 2006, what is the difference between the Value added (constant 2005 US$) of El Salvador and Value added (constant 2005 US$) of Japan?
Provide a succinct answer. -5.27e+1. In the year 2006, what is the difference between the Value added (constant 2005 US$) of El Salvador and Value added (constant 2005 US$) of Macedonia?
Your answer should be compact. 1.17e+09. In the year 2006, what is the difference between the Value added (constant 2005 US$) in Japan and Value added (constant 2005 US$) in Macedonia?
Your response must be concise. 5.39e+1. In the year 2007, what is the difference between the Value added (constant 2005 US$) in Colombia and Value added (constant 2005 US$) in El Salvador?
Your answer should be very brief. 1.01e+1. In the year 2007, what is the difference between the Value added (constant 2005 US$) of Colombia and Value added (constant 2005 US$) of Japan?
Provide a succinct answer. -4.59e+1. In the year 2007, what is the difference between the Value added (constant 2005 US$) of Colombia and Value added (constant 2005 US$) of Macedonia?
Provide a succinct answer. 1.14e+1. In the year 2007, what is the difference between the Value added (constant 2005 US$) of El Salvador and Value added (constant 2005 US$) of Japan?
Offer a very short reply. -5.60e+1. In the year 2007, what is the difference between the Value added (constant 2005 US$) of El Salvador and Value added (constant 2005 US$) of Macedonia?
Ensure brevity in your answer.  1.30e+09. In the year 2007, what is the difference between the Value added (constant 2005 US$) in Japan and Value added (constant 2005 US$) in Macedonia?
Provide a succinct answer. 5.73e+1. In the year 2008, what is the difference between the Value added (constant 2005 US$) in Colombia and Value added (constant 2005 US$) in El Salvador?
Give a very brief answer. 1.00e+1. In the year 2008, what is the difference between the Value added (constant 2005 US$) of Colombia and Value added (constant 2005 US$) of Japan?
Provide a succinct answer. -5.01e+1. In the year 2008, what is the difference between the Value added (constant 2005 US$) in Colombia and Value added (constant 2005 US$) in Macedonia?
Ensure brevity in your answer.  1.12e+1. In the year 2008, what is the difference between the Value added (constant 2005 US$) of El Salvador and Value added (constant 2005 US$) of Japan?
Provide a short and direct response. -6.01e+1. In the year 2008, what is the difference between the Value added (constant 2005 US$) of El Salvador and Value added (constant 2005 US$) of Macedonia?
Provide a short and direct response. 1.23e+09. In the year 2008, what is the difference between the Value added (constant 2005 US$) in Japan and Value added (constant 2005 US$) in Macedonia?
Make the answer very short. 6.13e+1. In the year 2009, what is the difference between the Value added (constant 2005 US$) in Colombia and Value added (constant 2005 US$) in El Salvador?
Give a very brief answer. 1.00e+1. In the year 2009, what is the difference between the Value added (constant 2005 US$) of Colombia and Value added (constant 2005 US$) of Japan?
Offer a terse response. -4.43e+1. In the year 2009, what is the difference between the Value added (constant 2005 US$) in Colombia and Value added (constant 2005 US$) in Macedonia?
Ensure brevity in your answer.  1.11e+1. In the year 2009, what is the difference between the Value added (constant 2005 US$) in El Salvador and Value added (constant 2005 US$) in Japan?
Provide a succinct answer. -5.43e+1. In the year 2009, what is the difference between the Value added (constant 2005 US$) in El Salvador and Value added (constant 2005 US$) in Macedonia?
Give a very brief answer. 1.14e+09. In the year 2009, what is the difference between the Value added (constant 2005 US$) in Japan and Value added (constant 2005 US$) in Macedonia?
Provide a short and direct response. 5.55e+1. What is the ratio of the Value added (constant 2005 US$) of Colombia in 2003 to that in 2004?
Offer a terse response. 0.97. What is the ratio of the Value added (constant 2005 US$) of El Salvador in 2003 to that in 2004?
Offer a terse response. 0.97. What is the ratio of the Value added (constant 2005 US$) in Japan in 2003 to that in 2004?
Provide a short and direct response. 1.11. What is the ratio of the Value added (constant 2005 US$) of Macedonia in 2003 to that in 2004?
Your answer should be very brief. 0.94. What is the ratio of the Value added (constant 2005 US$) of Colombia in 2003 to that in 2005?
Make the answer very short. 0.94. What is the ratio of the Value added (constant 2005 US$) of El Salvador in 2003 to that in 2005?
Offer a very short reply. 0.93. What is the ratio of the Value added (constant 2005 US$) in Japan in 2003 to that in 2005?
Keep it short and to the point. 1.1. What is the ratio of the Value added (constant 2005 US$) of Macedonia in 2003 to that in 2005?
Ensure brevity in your answer.  0.93. What is the ratio of the Value added (constant 2005 US$) of Colombia in 2003 to that in 2006?
Provide a short and direct response. 0.92. What is the ratio of the Value added (constant 2005 US$) of El Salvador in 2003 to that in 2006?
Make the answer very short. 0.88. What is the ratio of the Value added (constant 2005 US$) of Japan in 2003 to that in 2006?
Your answer should be very brief. 1.12. What is the ratio of the Value added (constant 2005 US$) in Macedonia in 2003 to that in 2006?
Make the answer very short. 0.93. What is the ratio of the Value added (constant 2005 US$) in Colombia in 2003 to that in 2007?
Offer a very short reply. 0.89. What is the ratio of the Value added (constant 2005 US$) of El Salvador in 2003 to that in 2007?
Make the answer very short. 0.81. What is the ratio of the Value added (constant 2005 US$) of Japan in 2003 to that in 2007?
Your answer should be very brief. 1.05. What is the ratio of the Value added (constant 2005 US$) of Macedonia in 2003 to that in 2007?
Offer a very short reply. 0.91. What is the ratio of the Value added (constant 2005 US$) of Colombia in 2003 to that in 2008?
Your response must be concise. 0.89. What is the ratio of the Value added (constant 2005 US$) of El Salvador in 2003 to that in 2008?
Give a very brief answer. 0.78. What is the ratio of the Value added (constant 2005 US$) of Japan in 2003 to that in 2008?
Provide a succinct answer. 0.98. What is the ratio of the Value added (constant 2005 US$) in Macedonia in 2003 to that in 2008?
Keep it short and to the point. 0.75. What is the ratio of the Value added (constant 2005 US$) of Colombia in 2003 to that in 2009?
Offer a terse response. 0.9. What is the ratio of the Value added (constant 2005 US$) of El Salvador in 2003 to that in 2009?
Make the answer very short. 0.81. What is the ratio of the Value added (constant 2005 US$) in Japan in 2003 to that in 2009?
Keep it short and to the point. 1.08. What is the ratio of the Value added (constant 2005 US$) of Macedonia in 2003 to that in 2009?
Your answer should be compact. 0.72. What is the ratio of the Value added (constant 2005 US$) of Colombia in 2004 to that in 2005?
Your answer should be very brief. 0.97. What is the ratio of the Value added (constant 2005 US$) in El Salvador in 2004 to that in 2005?
Your answer should be very brief. 0.95. What is the ratio of the Value added (constant 2005 US$) in Japan in 2004 to that in 2005?
Provide a short and direct response. 0.99. What is the ratio of the Value added (constant 2005 US$) of Colombia in 2004 to that in 2006?
Ensure brevity in your answer.  0.95. What is the ratio of the Value added (constant 2005 US$) in El Salvador in 2004 to that in 2006?
Offer a very short reply. 0.9. What is the ratio of the Value added (constant 2005 US$) in Macedonia in 2004 to that in 2006?
Your answer should be very brief. 1. What is the ratio of the Value added (constant 2005 US$) in Colombia in 2004 to that in 2007?
Your response must be concise. 0.91. What is the ratio of the Value added (constant 2005 US$) in El Salvador in 2004 to that in 2007?
Provide a succinct answer. 0.83. What is the ratio of the Value added (constant 2005 US$) in Japan in 2004 to that in 2007?
Your answer should be compact. 0.95. What is the ratio of the Value added (constant 2005 US$) of Macedonia in 2004 to that in 2007?
Give a very brief answer. 0.97. What is the ratio of the Value added (constant 2005 US$) in Colombia in 2004 to that in 2008?
Your response must be concise. 0.92. What is the ratio of the Value added (constant 2005 US$) of El Salvador in 2004 to that in 2008?
Provide a short and direct response. 0.81. What is the ratio of the Value added (constant 2005 US$) in Japan in 2004 to that in 2008?
Offer a very short reply. 0.88. What is the ratio of the Value added (constant 2005 US$) in Macedonia in 2004 to that in 2008?
Your answer should be compact. 0.8. What is the ratio of the Value added (constant 2005 US$) of Colombia in 2004 to that in 2009?
Your response must be concise. 0.92. What is the ratio of the Value added (constant 2005 US$) in El Salvador in 2004 to that in 2009?
Your response must be concise. 0.83. What is the ratio of the Value added (constant 2005 US$) of Japan in 2004 to that in 2009?
Offer a terse response. 0.98. What is the ratio of the Value added (constant 2005 US$) in Macedonia in 2004 to that in 2009?
Provide a succinct answer. 0.77. What is the ratio of the Value added (constant 2005 US$) of Colombia in 2005 to that in 2006?
Give a very brief answer. 0.98. What is the ratio of the Value added (constant 2005 US$) in El Salvador in 2005 to that in 2006?
Keep it short and to the point. 0.95. What is the ratio of the Value added (constant 2005 US$) of Japan in 2005 to that in 2006?
Your answer should be compact. 1.02. What is the ratio of the Value added (constant 2005 US$) of Colombia in 2005 to that in 2007?
Offer a terse response. 0.94. What is the ratio of the Value added (constant 2005 US$) in El Salvador in 2005 to that in 2007?
Offer a terse response. 0.87. What is the ratio of the Value added (constant 2005 US$) in Japan in 2005 to that in 2007?
Offer a terse response. 0.96. What is the ratio of the Value added (constant 2005 US$) in Macedonia in 2005 to that in 2007?
Keep it short and to the point. 0.98. What is the ratio of the Value added (constant 2005 US$) in Colombia in 2005 to that in 2008?
Offer a very short reply. 0.94. What is the ratio of the Value added (constant 2005 US$) of El Salvador in 2005 to that in 2008?
Give a very brief answer. 0.85. What is the ratio of the Value added (constant 2005 US$) of Japan in 2005 to that in 2008?
Ensure brevity in your answer.  0.89. What is the ratio of the Value added (constant 2005 US$) in Macedonia in 2005 to that in 2008?
Give a very brief answer. 0.81. What is the ratio of the Value added (constant 2005 US$) in Colombia in 2005 to that in 2009?
Your answer should be compact. 0.95. What is the ratio of the Value added (constant 2005 US$) in El Salvador in 2005 to that in 2009?
Offer a terse response. 0.87. What is the ratio of the Value added (constant 2005 US$) of Japan in 2005 to that in 2009?
Keep it short and to the point. 0.99. What is the ratio of the Value added (constant 2005 US$) in Macedonia in 2005 to that in 2009?
Make the answer very short. 0.78. What is the ratio of the Value added (constant 2005 US$) in Colombia in 2006 to that in 2007?
Ensure brevity in your answer.  0.96. What is the ratio of the Value added (constant 2005 US$) in El Salvador in 2006 to that in 2007?
Provide a short and direct response. 0.92. What is the ratio of the Value added (constant 2005 US$) of Japan in 2006 to that in 2007?
Your answer should be compact. 0.94. What is the ratio of the Value added (constant 2005 US$) of Macedonia in 2006 to that in 2007?
Your answer should be very brief. 0.98. What is the ratio of the Value added (constant 2005 US$) of El Salvador in 2006 to that in 2008?
Provide a succinct answer. 0.89. What is the ratio of the Value added (constant 2005 US$) of Japan in 2006 to that in 2008?
Provide a succinct answer. 0.88. What is the ratio of the Value added (constant 2005 US$) of Macedonia in 2006 to that in 2008?
Provide a succinct answer. 0.8. What is the ratio of the Value added (constant 2005 US$) in Colombia in 2006 to that in 2009?
Provide a short and direct response. 0.97. What is the ratio of the Value added (constant 2005 US$) of El Salvador in 2006 to that in 2009?
Your answer should be very brief. 0.92. What is the ratio of the Value added (constant 2005 US$) of Japan in 2006 to that in 2009?
Give a very brief answer. 0.97. What is the ratio of the Value added (constant 2005 US$) of Macedonia in 2006 to that in 2009?
Make the answer very short. 0.78. What is the ratio of the Value added (constant 2005 US$) of El Salvador in 2007 to that in 2008?
Give a very brief answer. 0.97. What is the ratio of the Value added (constant 2005 US$) in Japan in 2007 to that in 2008?
Your response must be concise. 0.93. What is the ratio of the Value added (constant 2005 US$) in Macedonia in 2007 to that in 2008?
Your answer should be compact. 0.82. What is the ratio of the Value added (constant 2005 US$) of Colombia in 2007 to that in 2009?
Give a very brief answer. 1.01. What is the ratio of the Value added (constant 2005 US$) of El Salvador in 2007 to that in 2009?
Offer a terse response. 1. What is the ratio of the Value added (constant 2005 US$) of Japan in 2007 to that in 2009?
Offer a terse response. 1.03. What is the ratio of the Value added (constant 2005 US$) in Macedonia in 2007 to that in 2009?
Give a very brief answer. 0.79. What is the ratio of the Value added (constant 2005 US$) of Colombia in 2008 to that in 2009?
Keep it short and to the point. 1.01. What is the ratio of the Value added (constant 2005 US$) of El Salvador in 2008 to that in 2009?
Make the answer very short. 1.03. What is the ratio of the Value added (constant 2005 US$) in Japan in 2008 to that in 2009?
Provide a short and direct response. 1.1. What is the ratio of the Value added (constant 2005 US$) in Macedonia in 2008 to that in 2009?
Ensure brevity in your answer.  0.97. What is the difference between the highest and the second highest Value added (constant 2005 US$) in Colombia?
Make the answer very short. 4.52e+07. What is the difference between the highest and the second highest Value added (constant 2005 US$) of El Salvador?
Keep it short and to the point. 5.73e+07. What is the difference between the highest and the second highest Value added (constant 2005 US$) in Japan?
Make the answer very short. 1.23e+09. What is the difference between the highest and the second highest Value added (constant 2005 US$) of Macedonia?
Your response must be concise. 2.57e+07. What is the difference between the highest and the lowest Value added (constant 2005 US$) of Colombia?
Keep it short and to the point. 1.35e+09. What is the difference between the highest and the lowest Value added (constant 2005 US$) in El Salvador?
Your answer should be very brief. 4.28e+08. What is the difference between the highest and the lowest Value added (constant 2005 US$) of Japan?
Give a very brief answer. 7.61e+09. What is the difference between the highest and the lowest Value added (constant 2005 US$) of Macedonia?
Offer a terse response. 2.16e+08. 